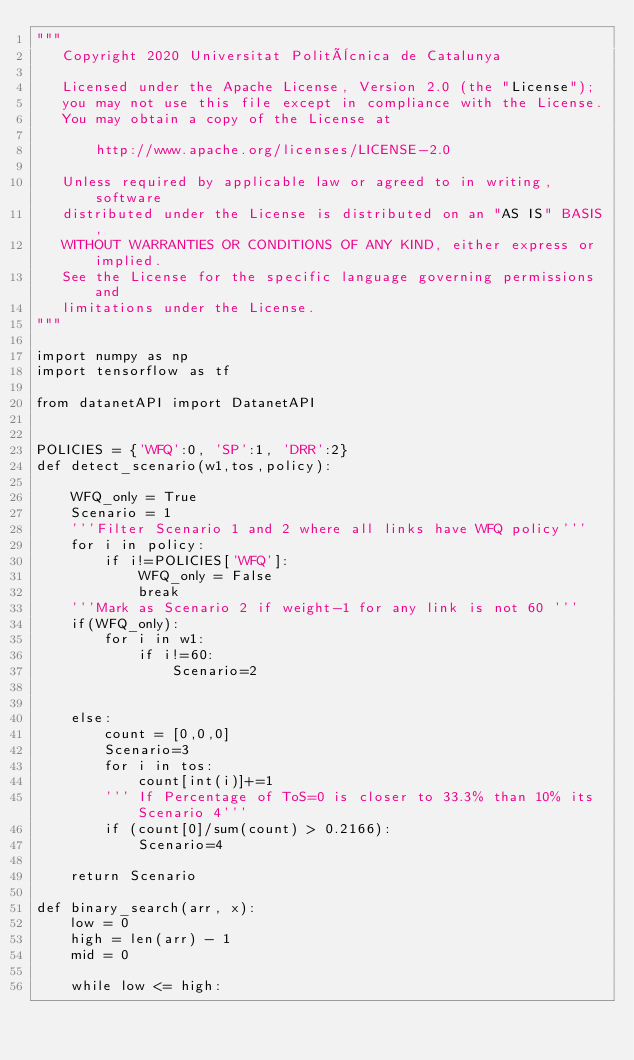<code> <loc_0><loc_0><loc_500><loc_500><_Python_>"""
   Copyright 2020 Universitat Politècnica de Catalunya

   Licensed under the Apache License, Version 2.0 (the "License");
   you may not use this file except in compliance with the License.
   You may obtain a copy of the License at

       http://www.apache.org/licenses/LICENSE-2.0

   Unless required by applicable law or agreed to in writing, software
   distributed under the License is distributed on an "AS IS" BASIS,
   WITHOUT WARRANTIES OR CONDITIONS OF ANY KIND, either express or implied.
   See the License for the specific language governing permissions and
   limitations under the License.
"""

import numpy as np
import tensorflow as tf

from datanetAPI import DatanetAPI


POLICIES = {'WFQ':0, 'SP':1, 'DRR':2}
def detect_scenario(w1,tos,policy):
    
    WFQ_only = True
    Scenario = 1
    '''Filter Scenario 1 and 2 where all links have WFQ policy'''
    for i in policy:
        if i!=POLICIES['WFQ']:
            WFQ_only = False
            break
    '''Mark as Scenario 2 if weight-1 for any link is not 60 ''' 
    if(WFQ_only):
        for i in w1:
            if i!=60:
                Scenario=2
                

    else:
        count = [0,0,0]
        Scenario=3
        for i in tos:
            count[int(i)]+=1
        ''' If Percentage of ToS=0 is closer to 33.3% than 10% its Scenario 4'''
        if (count[0]/sum(count) > 0.2166):
            Scenario=4
    
    return Scenario
         
def binary_search(arr, x): 
    low = 0
    high = len(arr) - 1
    mid = 0
  
    while low <= high: 
  </code> 